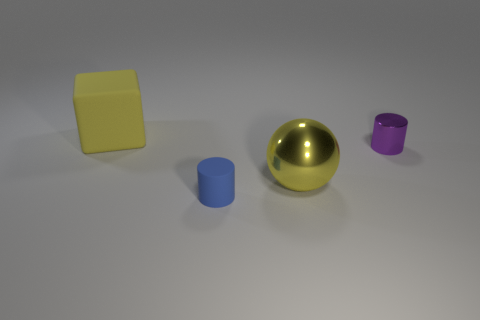Subtract 1 cylinders. How many cylinders are left? 1 Add 2 purple metallic cylinders. How many objects exist? 6 Subtract all purple cylinders. How many cylinders are left? 1 Subtract all blue cylinders. Subtract all purple spheres. How many cylinders are left? 1 Subtract all cyan balls. How many blue cylinders are left? 1 Subtract all big rubber cubes. Subtract all tiny shiny objects. How many objects are left? 2 Add 4 tiny rubber things. How many tiny rubber things are left? 5 Add 2 big gray matte objects. How many big gray matte objects exist? 2 Subtract 0 gray balls. How many objects are left? 4 Subtract all blocks. How many objects are left? 3 